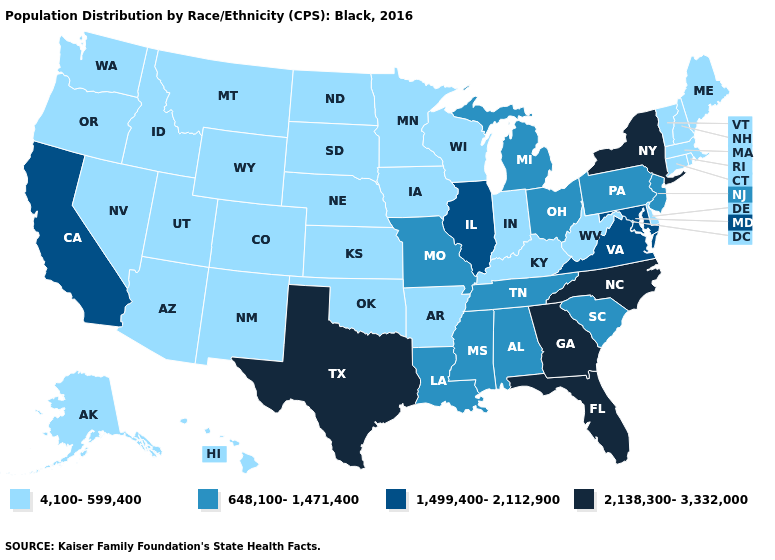What is the highest value in the USA?
Short answer required. 2,138,300-3,332,000. How many symbols are there in the legend?
Answer briefly. 4. What is the value of Kansas?
Quick response, please. 4,100-599,400. Does New York have the highest value in the Northeast?
Write a very short answer. Yes. Among the states that border Texas , which have the highest value?
Write a very short answer. Louisiana. What is the value of Kansas?
Quick response, please. 4,100-599,400. Does Pennsylvania have the lowest value in the Northeast?
Short answer required. No. Name the states that have a value in the range 1,499,400-2,112,900?
Answer briefly. California, Illinois, Maryland, Virginia. What is the highest value in states that border Iowa?
Concise answer only. 1,499,400-2,112,900. What is the value of Rhode Island?
Short answer required. 4,100-599,400. What is the highest value in the USA?
Answer briefly. 2,138,300-3,332,000. How many symbols are there in the legend?
Quick response, please. 4. What is the lowest value in the South?
Keep it brief. 4,100-599,400. Does California have the lowest value in the West?
Write a very short answer. No. 